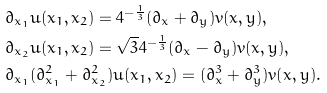Convert formula to latex. <formula><loc_0><loc_0><loc_500><loc_500>& \partial _ { x _ { 1 } } u ( x _ { 1 } , x _ { 2 } ) = 4 ^ { - \frac { 1 } { 3 } } ( \partial _ { x } + \partial _ { y } ) v ( x , y ) , \\ & \partial _ { x _ { 2 } } u ( x _ { 1 } , x _ { 2 } ) = \sqrt { 3 } 4 ^ { - \frac { 1 } { 3 } } ( \partial _ { x } - \partial _ { y } ) v ( x , y ) , \\ & \partial _ { x _ { 1 } } ( \partial _ { x _ { 1 } } ^ { 2 } + \partial _ { x _ { 2 } } ^ { 2 } ) u ( x _ { 1 } , x _ { 2 } ) = ( \partial _ { x } ^ { 3 } + \partial _ { y } ^ { 3 } ) v ( x , y ) .</formula> 